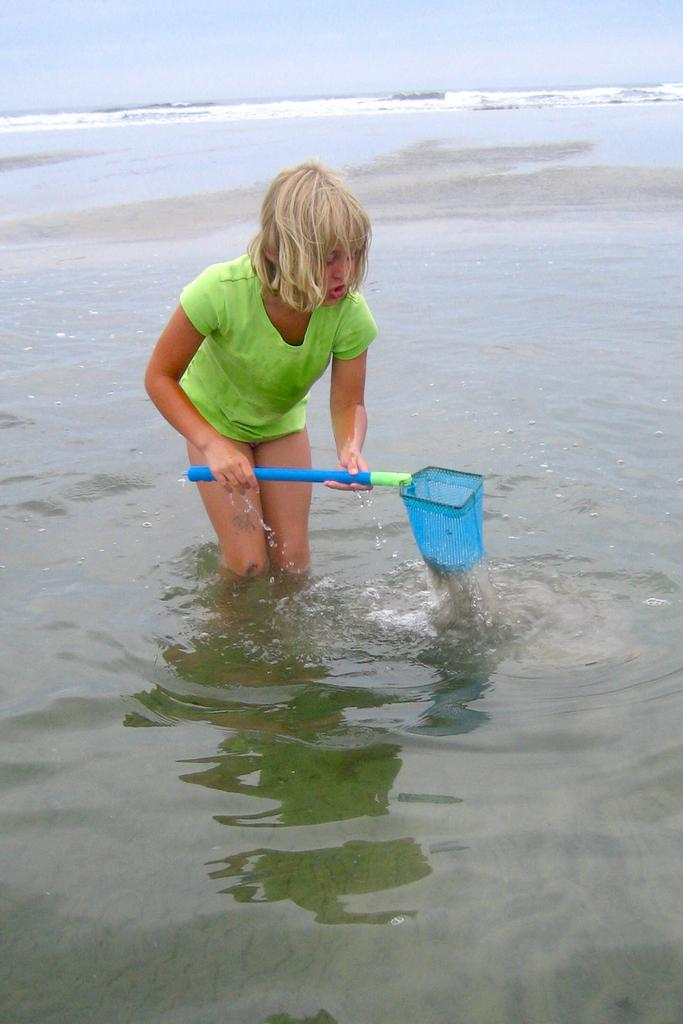Who is the main subject in the image? There is a woman in the image. What is the woman holding in the image? The woman is holding a stick. Where is the woman standing in the image? The woman is standing on water. What is visible at the top of the image? The sky is visible at the top of the image. What type of snails can be seen crawling on the camera in the image? There is no camera or snails present in the image. Is the woman in the image taking a picture of space? The image does not depict space or any indication of the woman taking a picture. 